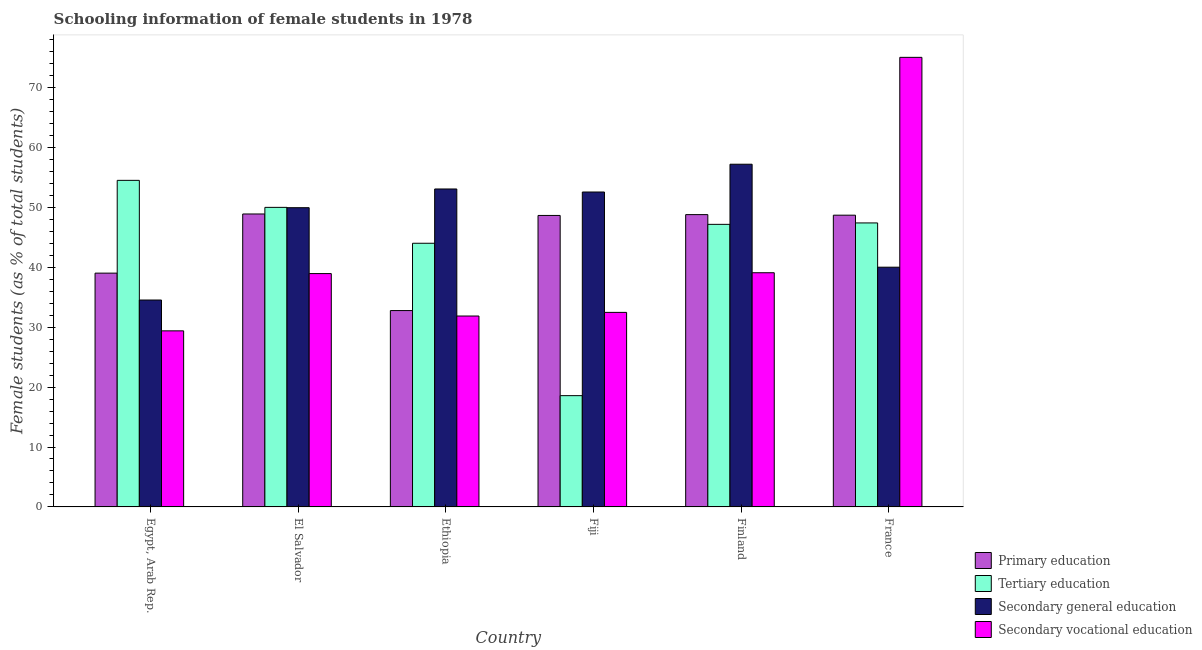How many different coloured bars are there?
Your answer should be very brief. 4. Are the number of bars per tick equal to the number of legend labels?
Provide a succinct answer. Yes. What is the label of the 1st group of bars from the left?
Provide a succinct answer. Egypt, Arab Rep. What is the percentage of female students in secondary vocational education in Ethiopia?
Ensure brevity in your answer.  31.87. Across all countries, what is the maximum percentage of female students in primary education?
Provide a succinct answer. 48.9. Across all countries, what is the minimum percentage of female students in secondary education?
Provide a succinct answer. 34.54. In which country was the percentage of female students in secondary vocational education maximum?
Provide a short and direct response. France. In which country was the percentage of female students in secondary vocational education minimum?
Ensure brevity in your answer.  Egypt, Arab Rep. What is the total percentage of female students in primary education in the graph?
Provide a succinct answer. 266.83. What is the difference between the percentage of female students in secondary vocational education in Egypt, Arab Rep. and that in El Salvador?
Provide a succinct answer. -9.56. What is the difference between the percentage of female students in tertiary education in Fiji and the percentage of female students in secondary education in Finland?
Keep it short and to the point. -38.63. What is the average percentage of female students in secondary education per country?
Ensure brevity in your answer.  47.89. What is the difference between the percentage of female students in primary education and percentage of female students in tertiary education in Ethiopia?
Keep it short and to the point. -11.24. What is the ratio of the percentage of female students in tertiary education in El Salvador to that in Ethiopia?
Keep it short and to the point. 1.14. Is the percentage of female students in tertiary education in Egypt, Arab Rep. less than that in Finland?
Offer a very short reply. No. Is the difference between the percentage of female students in secondary vocational education in Egypt, Arab Rep. and Finland greater than the difference between the percentage of female students in secondary education in Egypt, Arab Rep. and Finland?
Your answer should be compact. Yes. What is the difference between the highest and the second highest percentage of female students in secondary vocational education?
Provide a succinct answer. 35.95. What is the difference between the highest and the lowest percentage of female students in secondary vocational education?
Give a very brief answer. 45.65. In how many countries, is the percentage of female students in tertiary education greater than the average percentage of female students in tertiary education taken over all countries?
Keep it short and to the point. 5. Is the sum of the percentage of female students in secondary vocational education in Egypt, Arab Rep. and Ethiopia greater than the maximum percentage of female students in tertiary education across all countries?
Give a very brief answer. Yes. Is it the case that in every country, the sum of the percentage of female students in secondary vocational education and percentage of female students in tertiary education is greater than the sum of percentage of female students in secondary education and percentage of female students in primary education?
Provide a short and direct response. No. What does the 2nd bar from the left in Ethiopia represents?
Ensure brevity in your answer.  Tertiary education. What does the 4th bar from the right in El Salvador represents?
Provide a succinct answer. Primary education. How many countries are there in the graph?
Offer a very short reply. 6. Are the values on the major ticks of Y-axis written in scientific E-notation?
Your answer should be compact. No. How many legend labels are there?
Your answer should be compact. 4. What is the title of the graph?
Keep it short and to the point. Schooling information of female students in 1978. Does "WHO" appear as one of the legend labels in the graph?
Give a very brief answer. No. What is the label or title of the Y-axis?
Your answer should be compact. Female students (as % of total students). What is the Female students (as % of total students) in Primary education in Egypt, Arab Rep.?
Ensure brevity in your answer.  39.02. What is the Female students (as % of total students) of Tertiary education in Egypt, Arab Rep.?
Offer a terse response. 54.51. What is the Female students (as % of total students) in Secondary general education in Egypt, Arab Rep.?
Your response must be concise. 34.54. What is the Female students (as % of total students) in Secondary vocational education in Egypt, Arab Rep.?
Offer a terse response. 29.39. What is the Female students (as % of total students) of Primary education in El Salvador?
Offer a terse response. 48.9. What is the Female students (as % of total students) of Tertiary education in El Salvador?
Provide a succinct answer. 50. What is the Female students (as % of total students) of Secondary general education in El Salvador?
Offer a very short reply. 49.95. What is the Female students (as % of total students) of Secondary vocational education in El Salvador?
Make the answer very short. 38.95. What is the Female students (as % of total students) in Primary education in Ethiopia?
Provide a short and direct response. 32.78. What is the Female students (as % of total students) in Tertiary education in Ethiopia?
Offer a terse response. 44.01. What is the Female students (as % of total students) of Secondary general education in Ethiopia?
Your response must be concise. 53.07. What is the Female students (as % of total students) of Secondary vocational education in Ethiopia?
Give a very brief answer. 31.87. What is the Female students (as % of total students) in Primary education in Fiji?
Your answer should be very brief. 48.65. What is the Female students (as % of total students) of Tertiary education in Fiji?
Provide a short and direct response. 18.57. What is the Female students (as % of total students) of Secondary general education in Fiji?
Keep it short and to the point. 52.56. What is the Female students (as % of total students) of Secondary vocational education in Fiji?
Offer a terse response. 32.47. What is the Female students (as % of total students) of Primary education in Finland?
Provide a short and direct response. 48.79. What is the Female students (as % of total students) of Tertiary education in Finland?
Ensure brevity in your answer.  47.17. What is the Female students (as % of total students) of Secondary general education in Finland?
Offer a very short reply. 57.2. What is the Female students (as % of total students) of Secondary vocational education in Finland?
Keep it short and to the point. 39.09. What is the Female students (as % of total students) of Primary education in France?
Your response must be concise. 48.7. What is the Female students (as % of total students) of Tertiary education in France?
Offer a terse response. 47.4. What is the Female students (as % of total students) in Secondary general education in France?
Make the answer very short. 40.02. What is the Female students (as % of total students) in Secondary vocational education in France?
Make the answer very short. 75.04. Across all countries, what is the maximum Female students (as % of total students) in Primary education?
Provide a short and direct response. 48.9. Across all countries, what is the maximum Female students (as % of total students) in Tertiary education?
Offer a terse response. 54.51. Across all countries, what is the maximum Female students (as % of total students) in Secondary general education?
Keep it short and to the point. 57.2. Across all countries, what is the maximum Female students (as % of total students) in Secondary vocational education?
Your answer should be compact. 75.04. Across all countries, what is the minimum Female students (as % of total students) of Primary education?
Provide a short and direct response. 32.78. Across all countries, what is the minimum Female students (as % of total students) in Tertiary education?
Ensure brevity in your answer.  18.57. Across all countries, what is the minimum Female students (as % of total students) in Secondary general education?
Provide a succinct answer. 34.54. Across all countries, what is the minimum Female students (as % of total students) in Secondary vocational education?
Give a very brief answer. 29.39. What is the total Female students (as % of total students) in Primary education in the graph?
Keep it short and to the point. 266.83. What is the total Female students (as % of total students) of Tertiary education in the graph?
Ensure brevity in your answer.  261.66. What is the total Female students (as % of total students) of Secondary general education in the graph?
Keep it short and to the point. 287.33. What is the total Female students (as % of total students) of Secondary vocational education in the graph?
Your answer should be compact. 246.8. What is the difference between the Female students (as % of total students) of Primary education in Egypt, Arab Rep. and that in El Salvador?
Provide a succinct answer. -9.87. What is the difference between the Female students (as % of total students) of Tertiary education in Egypt, Arab Rep. and that in El Salvador?
Your answer should be very brief. 4.51. What is the difference between the Female students (as % of total students) of Secondary general education in Egypt, Arab Rep. and that in El Salvador?
Offer a terse response. -15.41. What is the difference between the Female students (as % of total students) in Secondary vocational education in Egypt, Arab Rep. and that in El Salvador?
Offer a terse response. -9.56. What is the difference between the Female students (as % of total students) of Primary education in Egypt, Arab Rep. and that in Ethiopia?
Make the answer very short. 6.25. What is the difference between the Female students (as % of total students) of Tertiary education in Egypt, Arab Rep. and that in Ethiopia?
Provide a short and direct response. 10.5. What is the difference between the Female students (as % of total students) in Secondary general education in Egypt, Arab Rep. and that in Ethiopia?
Your response must be concise. -18.53. What is the difference between the Female students (as % of total students) in Secondary vocational education in Egypt, Arab Rep. and that in Ethiopia?
Make the answer very short. -2.47. What is the difference between the Female students (as % of total students) of Primary education in Egypt, Arab Rep. and that in Fiji?
Offer a terse response. -9.63. What is the difference between the Female students (as % of total students) in Tertiary education in Egypt, Arab Rep. and that in Fiji?
Make the answer very short. 35.94. What is the difference between the Female students (as % of total students) in Secondary general education in Egypt, Arab Rep. and that in Fiji?
Your answer should be compact. -18.03. What is the difference between the Female students (as % of total students) in Secondary vocational education in Egypt, Arab Rep. and that in Fiji?
Keep it short and to the point. -3.08. What is the difference between the Female students (as % of total students) of Primary education in Egypt, Arab Rep. and that in Finland?
Provide a succinct answer. -9.77. What is the difference between the Female students (as % of total students) in Tertiary education in Egypt, Arab Rep. and that in Finland?
Your answer should be very brief. 7.34. What is the difference between the Female students (as % of total students) of Secondary general education in Egypt, Arab Rep. and that in Finland?
Your answer should be very brief. -22.67. What is the difference between the Female students (as % of total students) of Secondary vocational education in Egypt, Arab Rep. and that in Finland?
Offer a terse response. -9.7. What is the difference between the Female students (as % of total students) in Primary education in Egypt, Arab Rep. and that in France?
Provide a succinct answer. -9.67. What is the difference between the Female students (as % of total students) of Tertiary education in Egypt, Arab Rep. and that in France?
Ensure brevity in your answer.  7.11. What is the difference between the Female students (as % of total students) of Secondary general education in Egypt, Arab Rep. and that in France?
Your response must be concise. -5.48. What is the difference between the Female students (as % of total students) of Secondary vocational education in Egypt, Arab Rep. and that in France?
Ensure brevity in your answer.  -45.65. What is the difference between the Female students (as % of total students) in Primary education in El Salvador and that in Ethiopia?
Your answer should be compact. 16.12. What is the difference between the Female students (as % of total students) of Tertiary education in El Salvador and that in Ethiopia?
Offer a terse response. 5.99. What is the difference between the Female students (as % of total students) in Secondary general education in El Salvador and that in Ethiopia?
Make the answer very short. -3.12. What is the difference between the Female students (as % of total students) of Secondary vocational education in El Salvador and that in Ethiopia?
Your answer should be compact. 7.08. What is the difference between the Female students (as % of total students) of Primary education in El Salvador and that in Fiji?
Offer a very short reply. 0.25. What is the difference between the Female students (as % of total students) of Tertiary education in El Salvador and that in Fiji?
Your answer should be compact. 31.43. What is the difference between the Female students (as % of total students) in Secondary general education in El Salvador and that in Fiji?
Your response must be concise. -2.62. What is the difference between the Female students (as % of total students) in Secondary vocational education in El Salvador and that in Fiji?
Your response must be concise. 6.48. What is the difference between the Female students (as % of total students) in Primary education in El Salvador and that in Finland?
Your answer should be very brief. 0.11. What is the difference between the Female students (as % of total students) in Tertiary education in El Salvador and that in Finland?
Offer a very short reply. 2.83. What is the difference between the Female students (as % of total students) in Secondary general education in El Salvador and that in Finland?
Provide a succinct answer. -7.26. What is the difference between the Female students (as % of total students) of Secondary vocational education in El Salvador and that in Finland?
Keep it short and to the point. -0.14. What is the difference between the Female students (as % of total students) of Primary education in El Salvador and that in France?
Make the answer very short. 0.2. What is the difference between the Female students (as % of total students) of Tertiary education in El Salvador and that in France?
Give a very brief answer. 2.6. What is the difference between the Female students (as % of total students) in Secondary general education in El Salvador and that in France?
Make the answer very short. 9.93. What is the difference between the Female students (as % of total students) of Secondary vocational education in El Salvador and that in France?
Your answer should be very brief. -36.09. What is the difference between the Female students (as % of total students) of Primary education in Ethiopia and that in Fiji?
Your answer should be very brief. -15.88. What is the difference between the Female students (as % of total students) in Tertiary education in Ethiopia and that in Fiji?
Keep it short and to the point. 25.44. What is the difference between the Female students (as % of total students) in Secondary general education in Ethiopia and that in Fiji?
Your response must be concise. 0.51. What is the difference between the Female students (as % of total students) in Secondary vocational education in Ethiopia and that in Fiji?
Provide a short and direct response. -0.61. What is the difference between the Female students (as % of total students) in Primary education in Ethiopia and that in Finland?
Keep it short and to the point. -16.01. What is the difference between the Female students (as % of total students) in Tertiary education in Ethiopia and that in Finland?
Offer a very short reply. -3.16. What is the difference between the Female students (as % of total students) of Secondary general education in Ethiopia and that in Finland?
Keep it short and to the point. -4.13. What is the difference between the Female students (as % of total students) of Secondary vocational education in Ethiopia and that in Finland?
Provide a succinct answer. -7.22. What is the difference between the Female students (as % of total students) of Primary education in Ethiopia and that in France?
Offer a very short reply. -15.92. What is the difference between the Female students (as % of total students) of Tertiary education in Ethiopia and that in France?
Make the answer very short. -3.39. What is the difference between the Female students (as % of total students) of Secondary general education in Ethiopia and that in France?
Offer a terse response. 13.05. What is the difference between the Female students (as % of total students) of Secondary vocational education in Ethiopia and that in France?
Make the answer very short. -43.17. What is the difference between the Female students (as % of total students) in Primary education in Fiji and that in Finland?
Offer a terse response. -0.14. What is the difference between the Female students (as % of total students) in Tertiary education in Fiji and that in Finland?
Your response must be concise. -28.59. What is the difference between the Female students (as % of total students) in Secondary general education in Fiji and that in Finland?
Give a very brief answer. -4.64. What is the difference between the Female students (as % of total students) of Secondary vocational education in Fiji and that in Finland?
Your answer should be compact. -6.62. What is the difference between the Female students (as % of total students) in Primary education in Fiji and that in France?
Provide a succinct answer. -0.05. What is the difference between the Female students (as % of total students) of Tertiary education in Fiji and that in France?
Give a very brief answer. -28.83. What is the difference between the Female students (as % of total students) in Secondary general education in Fiji and that in France?
Offer a terse response. 12.55. What is the difference between the Female students (as % of total students) of Secondary vocational education in Fiji and that in France?
Offer a very short reply. -42.57. What is the difference between the Female students (as % of total students) in Primary education in Finland and that in France?
Your answer should be very brief. 0.09. What is the difference between the Female students (as % of total students) of Tertiary education in Finland and that in France?
Keep it short and to the point. -0.24. What is the difference between the Female students (as % of total students) of Secondary general education in Finland and that in France?
Provide a short and direct response. 17.19. What is the difference between the Female students (as % of total students) of Secondary vocational education in Finland and that in France?
Ensure brevity in your answer.  -35.95. What is the difference between the Female students (as % of total students) of Primary education in Egypt, Arab Rep. and the Female students (as % of total students) of Tertiary education in El Salvador?
Offer a terse response. -10.98. What is the difference between the Female students (as % of total students) of Primary education in Egypt, Arab Rep. and the Female students (as % of total students) of Secondary general education in El Salvador?
Provide a short and direct response. -10.92. What is the difference between the Female students (as % of total students) in Primary education in Egypt, Arab Rep. and the Female students (as % of total students) in Secondary vocational education in El Salvador?
Ensure brevity in your answer.  0.08. What is the difference between the Female students (as % of total students) of Tertiary education in Egypt, Arab Rep. and the Female students (as % of total students) of Secondary general education in El Salvador?
Provide a succinct answer. 4.57. What is the difference between the Female students (as % of total students) of Tertiary education in Egypt, Arab Rep. and the Female students (as % of total students) of Secondary vocational education in El Salvador?
Offer a terse response. 15.56. What is the difference between the Female students (as % of total students) in Secondary general education in Egypt, Arab Rep. and the Female students (as % of total students) in Secondary vocational education in El Salvador?
Make the answer very short. -4.41. What is the difference between the Female students (as % of total students) in Primary education in Egypt, Arab Rep. and the Female students (as % of total students) in Tertiary education in Ethiopia?
Keep it short and to the point. -4.99. What is the difference between the Female students (as % of total students) in Primary education in Egypt, Arab Rep. and the Female students (as % of total students) in Secondary general education in Ethiopia?
Ensure brevity in your answer.  -14.05. What is the difference between the Female students (as % of total students) in Primary education in Egypt, Arab Rep. and the Female students (as % of total students) in Secondary vocational education in Ethiopia?
Keep it short and to the point. 7.16. What is the difference between the Female students (as % of total students) of Tertiary education in Egypt, Arab Rep. and the Female students (as % of total students) of Secondary general education in Ethiopia?
Provide a short and direct response. 1.44. What is the difference between the Female students (as % of total students) in Tertiary education in Egypt, Arab Rep. and the Female students (as % of total students) in Secondary vocational education in Ethiopia?
Provide a succinct answer. 22.64. What is the difference between the Female students (as % of total students) in Secondary general education in Egypt, Arab Rep. and the Female students (as % of total students) in Secondary vocational education in Ethiopia?
Provide a succinct answer. 2.67. What is the difference between the Female students (as % of total students) of Primary education in Egypt, Arab Rep. and the Female students (as % of total students) of Tertiary education in Fiji?
Provide a succinct answer. 20.45. What is the difference between the Female students (as % of total students) in Primary education in Egypt, Arab Rep. and the Female students (as % of total students) in Secondary general education in Fiji?
Provide a succinct answer. -13.54. What is the difference between the Female students (as % of total students) in Primary education in Egypt, Arab Rep. and the Female students (as % of total students) in Secondary vocational education in Fiji?
Keep it short and to the point. 6.55. What is the difference between the Female students (as % of total students) of Tertiary education in Egypt, Arab Rep. and the Female students (as % of total students) of Secondary general education in Fiji?
Your response must be concise. 1.95. What is the difference between the Female students (as % of total students) of Tertiary education in Egypt, Arab Rep. and the Female students (as % of total students) of Secondary vocational education in Fiji?
Your response must be concise. 22.04. What is the difference between the Female students (as % of total students) in Secondary general education in Egypt, Arab Rep. and the Female students (as % of total students) in Secondary vocational education in Fiji?
Make the answer very short. 2.06. What is the difference between the Female students (as % of total students) in Primary education in Egypt, Arab Rep. and the Female students (as % of total students) in Tertiary education in Finland?
Keep it short and to the point. -8.14. What is the difference between the Female students (as % of total students) in Primary education in Egypt, Arab Rep. and the Female students (as % of total students) in Secondary general education in Finland?
Your answer should be compact. -18.18. What is the difference between the Female students (as % of total students) of Primary education in Egypt, Arab Rep. and the Female students (as % of total students) of Secondary vocational education in Finland?
Give a very brief answer. -0.06. What is the difference between the Female students (as % of total students) of Tertiary education in Egypt, Arab Rep. and the Female students (as % of total students) of Secondary general education in Finland?
Your answer should be very brief. -2.69. What is the difference between the Female students (as % of total students) of Tertiary education in Egypt, Arab Rep. and the Female students (as % of total students) of Secondary vocational education in Finland?
Provide a short and direct response. 15.42. What is the difference between the Female students (as % of total students) of Secondary general education in Egypt, Arab Rep. and the Female students (as % of total students) of Secondary vocational education in Finland?
Offer a terse response. -4.55. What is the difference between the Female students (as % of total students) in Primary education in Egypt, Arab Rep. and the Female students (as % of total students) in Tertiary education in France?
Offer a very short reply. -8.38. What is the difference between the Female students (as % of total students) of Primary education in Egypt, Arab Rep. and the Female students (as % of total students) of Secondary general education in France?
Your answer should be compact. -0.99. What is the difference between the Female students (as % of total students) in Primary education in Egypt, Arab Rep. and the Female students (as % of total students) in Secondary vocational education in France?
Your answer should be very brief. -36.02. What is the difference between the Female students (as % of total students) of Tertiary education in Egypt, Arab Rep. and the Female students (as % of total students) of Secondary general education in France?
Your answer should be very brief. 14.49. What is the difference between the Female students (as % of total students) in Tertiary education in Egypt, Arab Rep. and the Female students (as % of total students) in Secondary vocational education in France?
Offer a very short reply. -20.53. What is the difference between the Female students (as % of total students) of Secondary general education in Egypt, Arab Rep. and the Female students (as % of total students) of Secondary vocational education in France?
Offer a very short reply. -40.5. What is the difference between the Female students (as % of total students) of Primary education in El Salvador and the Female students (as % of total students) of Tertiary education in Ethiopia?
Your answer should be very brief. 4.89. What is the difference between the Female students (as % of total students) of Primary education in El Salvador and the Female students (as % of total students) of Secondary general education in Ethiopia?
Keep it short and to the point. -4.17. What is the difference between the Female students (as % of total students) in Primary education in El Salvador and the Female students (as % of total students) in Secondary vocational education in Ethiopia?
Your answer should be compact. 17.03. What is the difference between the Female students (as % of total students) in Tertiary education in El Salvador and the Female students (as % of total students) in Secondary general education in Ethiopia?
Keep it short and to the point. -3.07. What is the difference between the Female students (as % of total students) of Tertiary education in El Salvador and the Female students (as % of total students) of Secondary vocational education in Ethiopia?
Your answer should be compact. 18.13. What is the difference between the Female students (as % of total students) in Secondary general education in El Salvador and the Female students (as % of total students) in Secondary vocational education in Ethiopia?
Provide a succinct answer. 18.08. What is the difference between the Female students (as % of total students) of Primary education in El Salvador and the Female students (as % of total students) of Tertiary education in Fiji?
Your answer should be compact. 30.32. What is the difference between the Female students (as % of total students) in Primary education in El Salvador and the Female students (as % of total students) in Secondary general education in Fiji?
Keep it short and to the point. -3.67. What is the difference between the Female students (as % of total students) of Primary education in El Salvador and the Female students (as % of total students) of Secondary vocational education in Fiji?
Your answer should be compact. 16.42. What is the difference between the Female students (as % of total students) in Tertiary education in El Salvador and the Female students (as % of total students) in Secondary general education in Fiji?
Offer a terse response. -2.56. What is the difference between the Female students (as % of total students) in Tertiary education in El Salvador and the Female students (as % of total students) in Secondary vocational education in Fiji?
Give a very brief answer. 17.53. What is the difference between the Female students (as % of total students) of Secondary general education in El Salvador and the Female students (as % of total students) of Secondary vocational education in Fiji?
Your answer should be very brief. 17.47. What is the difference between the Female students (as % of total students) of Primary education in El Salvador and the Female students (as % of total students) of Tertiary education in Finland?
Your answer should be very brief. 1.73. What is the difference between the Female students (as % of total students) in Primary education in El Salvador and the Female students (as % of total students) in Secondary general education in Finland?
Ensure brevity in your answer.  -8.31. What is the difference between the Female students (as % of total students) in Primary education in El Salvador and the Female students (as % of total students) in Secondary vocational education in Finland?
Give a very brief answer. 9.81. What is the difference between the Female students (as % of total students) in Tertiary education in El Salvador and the Female students (as % of total students) in Secondary general education in Finland?
Make the answer very short. -7.2. What is the difference between the Female students (as % of total students) of Tertiary education in El Salvador and the Female students (as % of total students) of Secondary vocational education in Finland?
Offer a terse response. 10.91. What is the difference between the Female students (as % of total students) of Secondary general education in El Salvador and the Female students (as % of total students) of Secondary vocational education in Finland?
Give a very brief answer. 10.86. What is the difference between the Female students (as % of total students) in Primary education in El Salvador and the Female students (as % of total students) in Tertiary education in France?
Make the answer very short. 1.49. What is the difference between the Female students (as % of total students) in Primary education in El Salvador and the Female students (as % of total students) in Secondary general education in France?
Your response must be concise. 8.88. What is the difference between the Female students (as % of total students) of Primary education in El Salvador and the Female students (as % of total students) of Secondary vocational education in France?
Your answer should be very brief. -26.14. What is the difference between the Female students (as % of total students) of Tertiary education in El Salvador and the Female students (as % of total students) of Secondary general education in France?
Your response must be concise. 9.98. What is the difference between the Female students (as % of total students) of Tertiary education in El Salvador and the Female students (as % of total students) of Secondary vocational education in France?
Give a very brief answer. -25.04. What is the difference between the Female students (as % of total students) in Secondary general education in El Salvador and the Female students (as % of total students) in Secondary vocational education in France?
Give a very brief answer. -25.09. What is the difference between the Female students (as % of total students) of Primary education in Ethiopia and the Female students (as % of total students) of Tertiary education in Fiji?
Your answer should be compact. 14.2. What is the difference between the Female students (as % of total students) in Primary education in Ethiopia and the Female students (as % of total students) in Secondary general education in Fiji?
Provide a short and direct response. -19.79. What is the difference between the Female students (as % of total students) in Primary education in Ethiopia and the Female students (as % of total students) in Secondary vocational education in Fiji?
Give a very brief answer. 0.3. What is the difference between the Female students (as % of total students) of Tertiary education in Ethiopia and the Female students (as % of total students) of Secondary general education in Fiji?
Give a very brief answer. -8.55. What is the difference between the Female students (as % of total students) of Tertiary education in Ethiopia and the Female students (as % of total students) of Secondary vocational education in Fiji?
Offer a terse response. 11.54. What is the difference between the Female students (as % of total students) of Secondary general education in Ethiopia and the Female students (as % of total students) of Secondary vocational education in Fiji?
Your answer should be compact. 20.6. What is the difference between the Female students (as % of total students) in Primary education in Ethiopia and the Female students (as % of total students) in Tertiary education in Finland?
Give a very brief answer. -14.39. What is the difference between the Female students (as % of total students) in Primary education in Ethiopia and the Female students (as % of total students) in Secondary general education in Finland?
Your answer should be very brief. -24.43. What is the difference between the Female students (as % of total students) in Primary education in Ethiopia and the Female students (as % of total students) in Secondary vocational education in Finland?
Your answer should be compact. -6.31. What is the difference between the Female students (as % of total students) of Tertiary education in Ethiopia and the Female students (as % of total students) of Secondary general education in Finland?
Provide a succinct answer. -13.19. What is the difference between the Female students (as % of total students) in Tertiary education in Ethiopia and the Female students (as % of total students) in Secondary vocational education in Finland?
Keep it short and to the point. 4.92. What is the difference between the Female students (as % of total students) in Secondary general education in Ethiopia and the Female students (as % of total students) in Secondary vocational education in Finland?
Ensure brevity in your answer.  13.98. What is the difference between the Female students (as % of total students) of Primary education in Ethiopia and the Female students (as % of total students) of Tertiary education in France?
Offer a very short reply. -14.63. What is the difference between the Female students (as % of total students) of Primary education in Ethiopia and the Female students (as % of total students) of Secondary general education in France?
Your answer should be very brief. -7.24. What is the difference between the Female students (as % of total students) of Primary education in Ethiopia and the Female students (as % of total students) of Secondary vocational education in France?
Ensure brevity in your answer.  -42.26. What is the difference between the Female students (as % of total students) of Tertiary education in Ethiopia and the Female students (as % of total students) of Secondary general education in France?
Your answer should be compact. 3.99. What is the difference between the Female students (as % of total students) of Tertiary education in Ethiopia and the Female students (as % of total students) of Secondary vocational education in France?
Provide a succinct answer. -31.03. What is the difference between the Female students (as % of total students) in Secondary general education in Ethiopia and the Female students (as % of total students) in Secondary vocational education in France?
Your response must be concise. -21.97. What is the difference between the Female students (as % of total students) of Primary education in Fiji and the Female students (as % of total students) of Tertiary education in Finland?
Offer a very short reply. 1.49. What is the difference between the Female students (as % of total students) in Primary education in Fiji and the Female students (as % of total students) in Secondary general education in Finland?
Offer a terse response. -8.55. What is the difference between the Female students (as % of total students) of Primary education in Fiji and the Female students (as % of total students) of Secondary vocational education in Finland?
Offer a terse response. 9.56. What is the difference between the Female students (as % of total students) in Tertiary education in Fiji and the Female students (as % of total students) in Secondary general education in Finland?
Offer a very short reply. -38.63. What is the difference between the Female students (as % of total students) in Tertiary education in Fiji and the Female students (as % of total students) in Secondary vocational education in Finland?
Your response must be concise. -20.51. What is the difference between the Female students (as % of total students) of Secondary general education in Fiji and the Female students (as % of total students) of Secondary vocational education in Finland?
Offer a terse response. 13.48. What is the difference between the Female students (as % of total students) in Primary education in Fiji and the Female students (as % of total students) in Tertiary education in France?
Your answer should be compact. 1.25. What is the difference between the Female students (as % of total students) in Primary education in Fiji and the Female students (as % of total students) in Secondary general education in France?
Offer a very short reply. 8.64. What is the difference between the Female students (as % of total students) of Primary education in Fiji and the Female students (as % of total students) of Secondary vocational education in France?
Offer a very short reply. -26.39. What is the difference between the Female students (as % of total students) in Tertiary education in Fiji and the Female students (as % of total students) in Secondary general education in France?
Your answer should be compact. -21.44. What is the difference between the Female students (as % of total students) of Tertiary education in Fiji and the Female students (as % of total students) of Secondary vocational education in France?
Ensure brevity in your answer.  -56.47. What is the difference between the Female students (as % of total students) of Secondary general education in Fiji and the Female students (as % of total students) of Secondary vocational education in France?
Offer a very short reply. -22.48. What is the difference between the Female students (as % of total students) of Primary education in Finland and the Female students (as % of total students) of Tertiary education in France?
Your answer should be compact. 1.39. What is the difference between the Female students (as % of total students) in Primary education in Finland and the Female students (as % of total students) in Secondary general education in France?
Keep it short and to the point. 8.77. What is the difference between the Female students (as % of total students) in Primary education in Finland and the Female students (as % of total students) in Secondary vocational education in France?
Provide a short and direct response. -26.25. What is the difference between the Female students (as % of total students) in Tertiary education in Finland and the Female students (as % of total students) in Secondary general education in France?
Offer a very short reply. 7.15. What is the difference between the Female students (as % of total students) in Tertiary education in Finland and the Female students (as % of total students) in Secondary vocational education in France?
Your response must be concise. -27.87. What is the difference between the Female students (as % of total students) of Secondary general education in Finland and the Female students (as % of total students) of Secondary vocational education in France?
Your answer should be very brief. -17.84. What is the average Female students (as % of total students) in Primary education per country?
Offer a very short reply. 44.47. What is the average Female students (as % of total students) of Tertiary education per country?
Provide a succinct answer. 43.61. What is the average Female students (as % of total students) in Secondary general education per country?
Your answer should be very brief. 47.89. What is the average Female students (as % of total students) in Secondary vocational education per country?
Make the answer very short. 41.13. What is the difference between the Female students (as % of total students) in Primary education and Female students (as % of total students) in Tertiary education in Egypt, Arab Rep.?
Keep it short and to the point. -15.49. What is the difference between the Female students (as % of total students) in Primary education and Female students (as % of total students) in Secondary general education in Egypt, Arab Rep.?
Ensure brevity in your answer.  4.49. What is the difference between the Female students (as % of total students) of Primary education and Female students (as % of total students) of Secondary vocational education in Egypt, Arab Rep.?
Offer a terse response. 9.63. What is the difference between the Female students (as % of total students) of Tertiary education and Female students (as % of total students) of Secondary general education in Egypt, Arab Rep.?
Provide a short and direct response. 19.97. What is the difference between the Female students (as % of total students) in Tertiary education and Female students (as % of total students) in Secondary vocational education in Egypt, Arab Rep.?
Your response must be concise. 25.12. What is the difference between the Female students (as % of total students) of Secondary general education and Female students (as % of total students) of Secondary vocational education in Egypt, Arab Rep.?
Your answer should be compact. 5.15. What is the difference between the Female students (as % of total students) in Primary education and Female students (as % of total students) in Tertiary education in El Salvador?
Offer a terse response. -1.1. What is the difference between the Female students (as % of total students) in Primary education and Female students (as % of total students) in Secondary general education in El Salvador?
Provide a succinct answer. -1.05. What is the difference between the Female students (as % of total students) of Primary education and Female students (as % of total students) of Secondary vocational education in El Salvador?
Keep it short and to the point. 9.95. What is the difference between the Female students (as % of total students) in Tertiary education and Female students (as % of total students) in Secondary general education in El Salvador?
Offer a very short reply. 0.05. What is the difference between the Female students (as % of total students) of Tertiary education and Female students (as % of total students) of Secondary vocational education in El Salvador?
Offer a terse response. 11.05. What is the difference between the Female students (as % of total students) in Secondary general education and Female students (as % of total students) in Secondary vocational education in El Salvador?
Provide a short and direct response. 11. What is the difference between the Female students (as % of total students) of Primary education and Female students (as % of total students) of Tertiary education in Ethiopia?
Offer a very short reply. -11.24. What is the difference between the Female students (as % of total students) of Primary education and Female students (as % of total students) of Secondary general education in Ethiopia?
Make the answer very short. -20.29. What is the difference between the Female students (as % of total students) in Primary education and Female students (as % of total students) in Secondary vocational education in Ethiopia?
Your response must be concise. 0.91. What is the difference between the Female students (as % of total students) of Tertiary education and Female students (as % of total students) of Secondary general education in Ethiopia?
Provide a succinct answer. -9.06. What is the difference between the Female students (as % of total students) in Tertiary education and Female students (as % of total students) in Secondary vocational education in Ethiopia?
Provide a short and direct response. 12.15. What is the difference between the Female students (as % of total students) of Secondary general education and Female students (as % of total students) of Secondary vocational education in Ethiopia?
Your answer should be very brief. 21.2. What is the difference between the Female students (as % of total students) in Primary education and Female students (as % of total students) in Tertiary education in Fiji?
Offer a terse response. 30.08. What is the difference between the Female students (as % of total students) of Primary education and Female students (as % of total students) of Secondary general education in Fiji?
Provide a succinct answer. -3.91. What is the difference between the Female students (as % of total students) in Primary education and Female students (as % of total students) in Secondary vocational education in Fiji?
Keep it short and to the point. 16.18. What is the difference between the Female students (as % of total students) of Tertiary education and Female students (as % of total students) of Secondary general education in Fiji?
Provide a succinct answer. -33.99. What is the difference between the Female students (as % of total students) in Tertiary education and Female students (as % of total students) in Secondary vocational education in Fiji?
Offer a terse response. -13.9. What is the difference between the Female students (as % of total students) of Secondary general education and Female students (as % of total students) of Secondary vocational education in Fiji?
Offer a terse response. 20.09. What is the difference between the Female students (as % of total students) of Primary education and Female students (as % of total students) of Tertiary education in Finland?
Make the answer very short. 1.62. What is the difference between the Female students (as % of total students) of Primary education and Female students (as % of total students) of Secondary general education in Finland?
Offer a terse response. -8.41. What is the difference between the Female students (as % of total students) of Primary education and Female students (as % of total students) of Secondary vocational education in Finland?
Your response must be concise. 9.7. What is the difference between the Female students (as % of total students) in Tertiary education and Female students (as % of total students) in Secondary general education in Finland?
Offer a very short reply. -10.04. What is the difference between the Female students (as % of total students) in Tertiary education and Female students (as % of total students) in Secondary vocational education in Finland?
Your answer should be very brief. 8.08. What is the difference between the Female students (as % of total students) of Secondary general education and Female students (as % of total students) of Secondary vocational education in Finland?
Your response must be concise. 18.11. What is the difference between the Female students (as % of total students) in Primary education and Female students (as % of total students) in Tertiary education in France?
Offer a terse response. 1.29. What is the difference between the Female students (as % of total students) of Primary education and Female students (as % of total students) of Secondary general education in France?
Keep it short and to the point. 8.68. What is the difference between the Female students (as % of total students) in Primary education and Female students (as % of total students) in Secondary vocational education in France?
Your answer should be very brief. -26.34. What is the difference between the Female students (as % of total students) in Tertiary education and Female students (as % of total students) in Secondary general education in France?
Your answer should be compact. 7.39. What is the difference between the Female students (as % of total students) of Tertiary education and Female students (as % of total students) of Secondary vocational education in France?
Keep it short and to the point. -27.64. What is the difference between the Female students (as % of total students) in Secondary general education and Female students (as % of total students) in Secondary vocational education in France?
Offer a terse response. -35.02. What is the ratio of the Female students (as % of total students) in Primary education in Egypt, Arab Rep. to that in El Salvador?
Provide a succinct answer. 0.8. What is the ratio of the Female students (as % of total students) of Tertiary education in Egypt, Arab Rep. to that in El Salvador?
Provide a succinct answer. 1.09. What is the ratio of the Female students (as % of total students) in Secondary general education in Egypt, Arab Rep. to that in El Salvador?
Offer a very short reply. 0.69. What is the ratio of the Female students (as % of total students) of Secondary vocational education in Egypt, Arab Rep. to that in El Salvador?
Provide a short and direct response. 0.75. What is the ratio of the Female students (as % of total students) in Primary education in Egypt, Arab Rep. to that in Ethiopia?
Your response must be concise. 1.19. What is the ratio of the Female students (as % of total students) in Tertiary education in Egypt, Arab Rep. to that in Ethiopia?
Your answer should be very brief. 1.24. What is the ratio of the Female students (as % of total students) of Secondary general education in Egypt, Arab Rep. to that in Ethiopia?
Provide a short and direct response. 0.65. What is the ratio of the Female students (as % of total students) of Secondary vocational education in Egypt, Arab Rep. to that in Ethiopia?
Make the answer very short. 0.92. What is the ratio of the Female students (as % of total students) in Primary education in Egypt, Arab Rep. to that in Fiji?
Ensure brevity in your answer.  0.8. What is the ratio of the Female students (as % of total students) of Tertiary education in Egypt, Arab Rep. to that in Fiji?
Your answer should be compact. 2.93. What is the ratio of the Female students (as % of total students) in Secondary general education in Egypt, Arab Rep. to that in Fiji?
Your answer should be very brief. 0.66. What is the ratio of the Female students (as % of total students) in Secondary vocational education in Egypt, Arab Rep. to that in Fiji?
Offer a very short reply. 0.91. What is the ratio of the Female students (as % of total students) of Primary education in Egypt, Arab Rep. to that in Finland?
Your response must be concise. 0.8. What is the ratio of the Female students (as % of total students) in Tertiary education in Egypt, Arab Rep. to that in Finland?
Give a very brief answer. 1.16. What is the ratio of the Female students (as % of total students) in Secondary general education in Egypt, Arab Rep. to that in Finland?
Your response must be concise. 0.6. What is the ratio of the Female students (as % of total students) of Secondary vocational education in Egypt, Arab Rep. to that in Finland?
Offer a terse response. 0.75. What is the ratio of the Female students (as % of total students) of Primary education in Egypt, Arab Rep. to that in France?
Ensure brevity in your answer.  0.8. What is the ratio of the Female students (as % of total students) of Tertiary education in Egypt, Arab Rep. to that in France?
Keep it short and to the point. 1.15. What is the ratio of the Female students (as % of total students) of Secondary general education in Egypt, Arab Rep. to that in France?
Give a very brief answer. 0.86. What is the ratio of the Female students (as % of total students) of Secondary vocational education in Egypt, Arab Rep. to that in France?
Offer a terse response. 0.39. What is the ratio of the Female students (as % of total students) of Primary education in El Salvador to that in Ethiopia?
Provide a succinct answer. 1.49. What is the ratio of the Female students (as % of total students) of Tertiary education in El Salvador to that in Ethiopia?
Make the answer very short. 1.14. What is the ratio of the Female students (as % of total students) in Secondary general education in El Salvador to that in Ethiopia?
Your answer should be compact. 0.94. What is the ratio of the Female students (as % of total students) of Secondary vocational education in El Salvador to that in Ethiopia?
Your answer should be very brief. 1.22. What is the ratio of the Female students (as % of total students) in Tertiary education in El Salvador to that in Fiji?
Provide a short and direct response. 2.69. What is the ratio of the Female students (as % of total students) in Secondary general education in El Salvador to that in Fiji?
Your answer should be compact. 0.95. What is the ratio of the Female students (as % of total students) in Secondary vocational education in El Salvador to that in Fiji?
Your answer should be very brief. 1.2. What is the ratio of the Female students (as % of total students) in Tertiary education in El Salvador to that in Finland?
Offer a very short reply. 1.06. What is the ratio of the Female students (as % of total students) in Secondary general education in El Salvador to that in Finland?
Provide a succinct answer. 0.87. What is the ratio of the Female students (as % of total students) in Primary education in El Salvador to that in France?
Offer a terse response. 1. What is the ratio of the Female students (as % of total students) of Tertiary education in El Salvador to that in France?
Provide a succinct answer. 1.05. What is the ratio of the Female students (as % of total students) of Secondary general education in El Salvador to that in France?
Your answer should be compact. 1.25. What is the ratio of the Female students (as % of total students) of Secondary vocational education in El Salvador to that in France?
Your response must be concise. 0.52. What is the ratio of the Female students (as % of total students) in Primary education in Ethiopia to that in Fiji?
Keep it short and to the point. 0.67. What is the ratio of the Female students (as % of total students) in Tertiary education in Ethiopia to that in Fiji?
Your answer should be very brief. 2.37. What is the ratio of the Female students (as % of total students) in Secondary general education in Ethiopia to that in Fiji?
Ensure brevity in your answer.  1.01. What is the ratio of the Female students (as % of total students) in Secondary vocational education in Ethiopia to that in Fiji?
Provide a short and direct response. 0.98. What is the ratio of the Female students (as % of total students) in Primary education in Ethiopia to that in Finland?
Make the answer very short. 0.67. What is the ratio of the Female students (as % of total students) in Tertiary education in Ethiopia to that in Finland?
Provide a short and direct response. 0.93. What is the ratio of the Female students (as % of total students) in Secondary general education in Ethiopia to that in Finland?
Provide a succinct answer. 0.93. What is the ratio of the Female students (as % of total students) of Secondary vocational education in Ethiopia to that in Finland?
Offer a very short reply. 0.82. What is the ratio of the Female students (as % of total students) of Primary education in Ethiopia to that in France?
Make the answer very short. 0.67. What is the ratio of the Female students (as % of total students) in Tertiary education in Ethiopia to that in France?
Keep it short and to the point. 0.93. What is the ratio of the Female students (as % of total students) in Secondary general education in Ethiopia to that in France?
Your answer should be very brief. 1.33. What is the ratio of the Female students (as % of total students) of Secondary vocational education in Ethiopia to that in France?
Give a very brief answer. 0.42. What is the ratio of the Female students (as % of total students) in Primary education in Fiji to that in Finland?
Provide a succinct answer. 1. What is the ratio of the Female students (as % of total students) of Tertiary education in Fiji to that in Finland?
Offer a very short reply. 0.39. What is the ratio of the Female students (as % of total students) of Secondary general education in Fiji to that in Finland?
Give a very brief answer. 0.92. What is the ratio of the Female students (as % of total students) in Secondary vocational education in Fiji to that in Finland?
Your answer should be very brief. 0.83. What is the ratio of the Female students (as % of total students) of Tertiary education in Fiji to that in France?
Provide a short and direct response. 0.39. What is the ratio of the Female students (as % of total students) of Secondary general education in Fiji to that in France?
Your answer should be very brief. 1.31. What is the ratio of the Female students (as % of total students) of Secondary vocational education in Fiji to that in France?
Provide a succinct answer. 0.43. What is the ratio of the Female students (as % of total students) of Secondary general education in Finland to that in France?
Your response must be concise. 1.43. What is the ratio of the Female students (as % of total students) of Secondary vocational education in Finland to that in France?
Give a very brief answer. 0.52. What is the difference between the highest and the second highest Female students (as % of total students) of Primary education?
Your answer should be compact. 0.11. What is the difference between the highest and the second highest Female students (as % of total students) of Tertiary education?
Your response must be concise. 4.51. What is the difference between the highest and the second highest Female students (as % of total students) in Secondary general education?
Your answer should be very brief. 4.13. What is the difference between the highest and the second highest Female students (as % of total students) in Secondary vocational education?
Ensure brevity in your answer.  35.95. What is the difference between the highest and the lowest Female students (as % of total students) in Primary education?
Offer a very short reply. 16.12. What is the difference between the highest and the lowest Female students (as % of total students) of Tertiary education?
Offer a terse response. 35.94. What is the difference between the highest and the lowest Female students (as % of total students) in Secondary general education?
Make the answer very short. 22.67. What is the difference between the highest and the lowest Female students (as % of total students) of Secondary vocational education?
Provide a short and direct response. 45.65. 